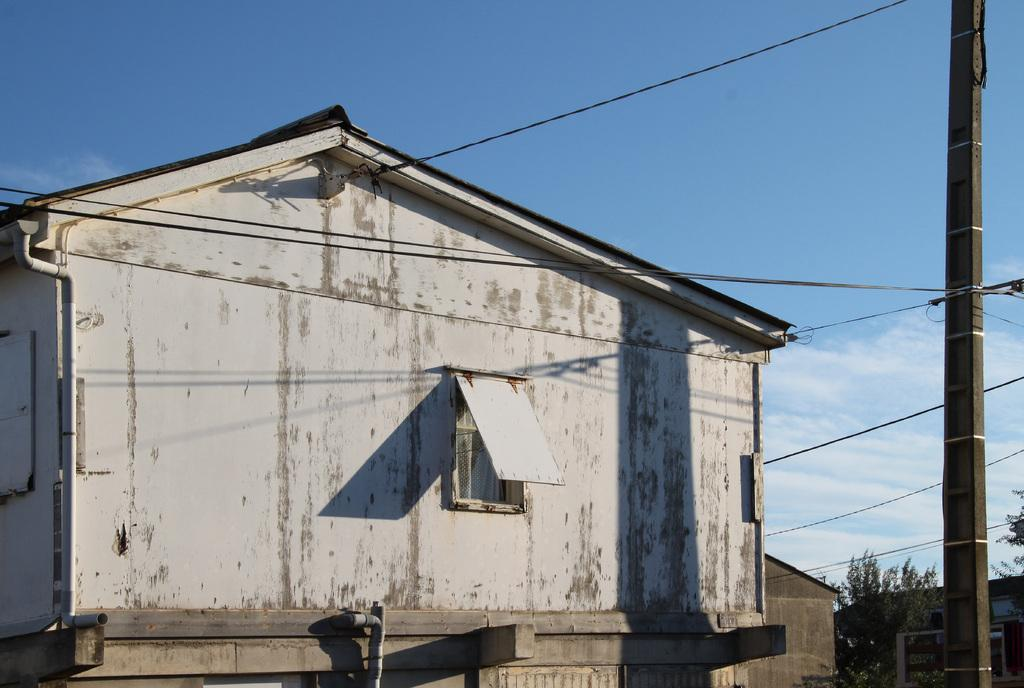What type of structure is visible in the image? There is a house in the image. What part of the natural environment is visible in the image? The sky is visible at the top of the image. Where is the scarecrow standing in the image? There is no scarecrow present in the image. What type of fruit is hanging from the beam in the image? There is no beam or cherries present in the image. 